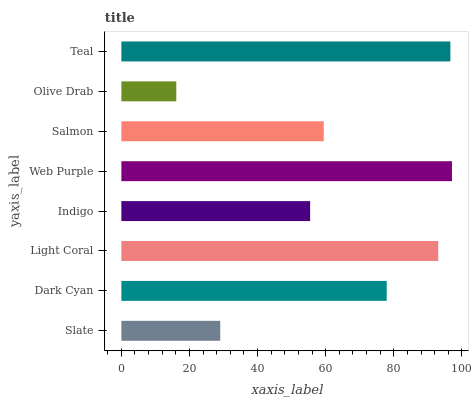Is Olive Drab the minimum?
Answer yes or no. Yes. Is Web Purple the maximum?
Answer yes or no. Yes. Is Dark Cyan the minimum?
Answer yes or no. No. Is Dark Cyan the maximum?
Answer yes or no. No. Is Dark Cyan greater than Slate?
Answer yes or no. Yes. Is Slate less than Dark Cyan?
Answer yes or no. Yes. Is Slate greater than Dark Cyan?
Answer yes or no. No. Is Dark Cyan less than Slate?
Answer yes or no. No. Is Dark Cyan the high median?
Answer yes or no. Yes. Is Salmon the low median?
Answer yes or no. Yes. Is Web Purple the high median?
Answer yes or no. No. Is Indigo the low median?
Answer yes or no. No. 